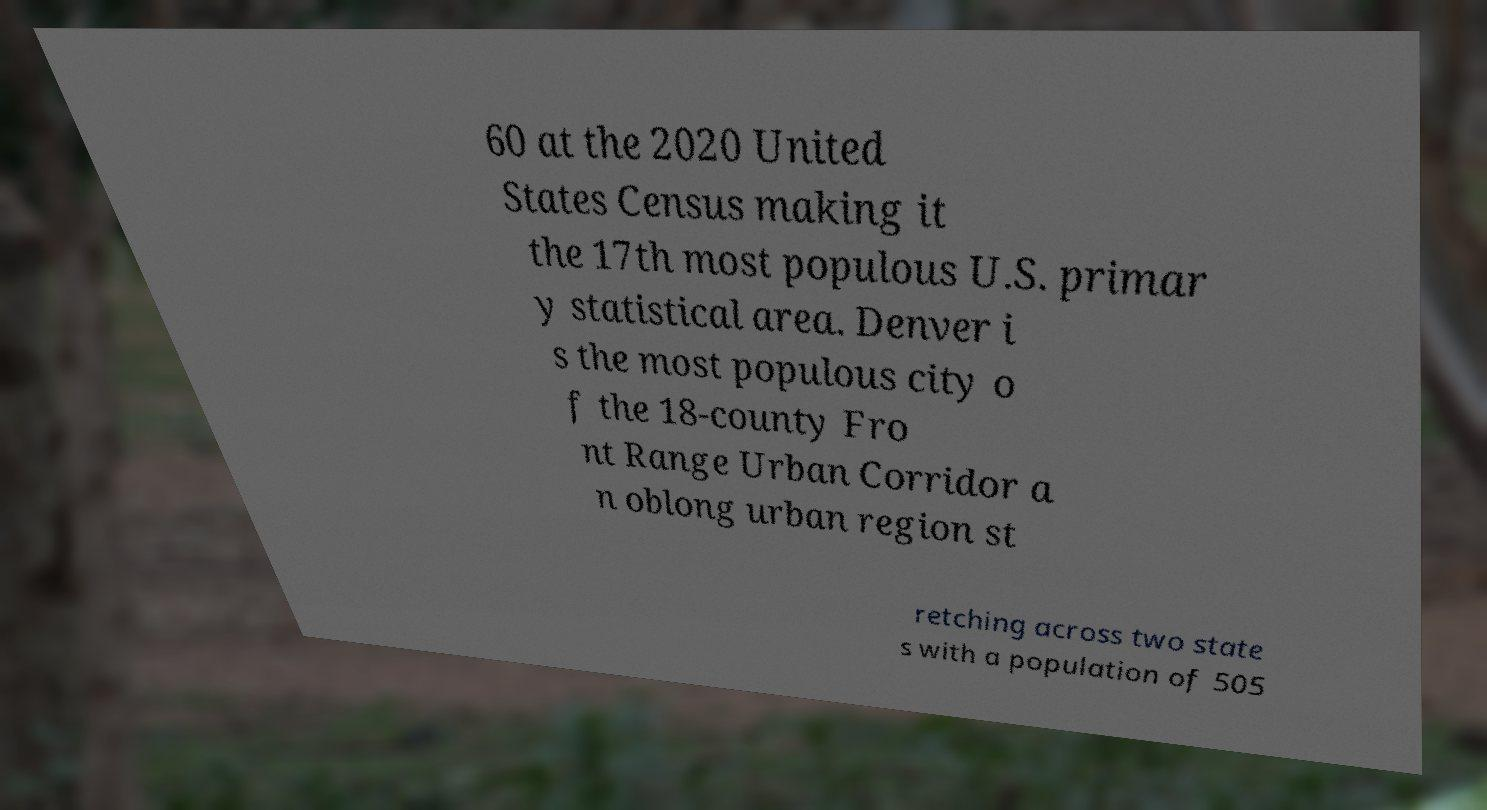Please read and relay the text visible in this image. What does it say? 60 at the 2020 United States Census making it the 17th most populous U.S. primar y statistical area. Denver i s the most populous city o f the 18-county Fro nt Range Urban Corridor a n oblong urban region st retching across two state s with a population of 505 